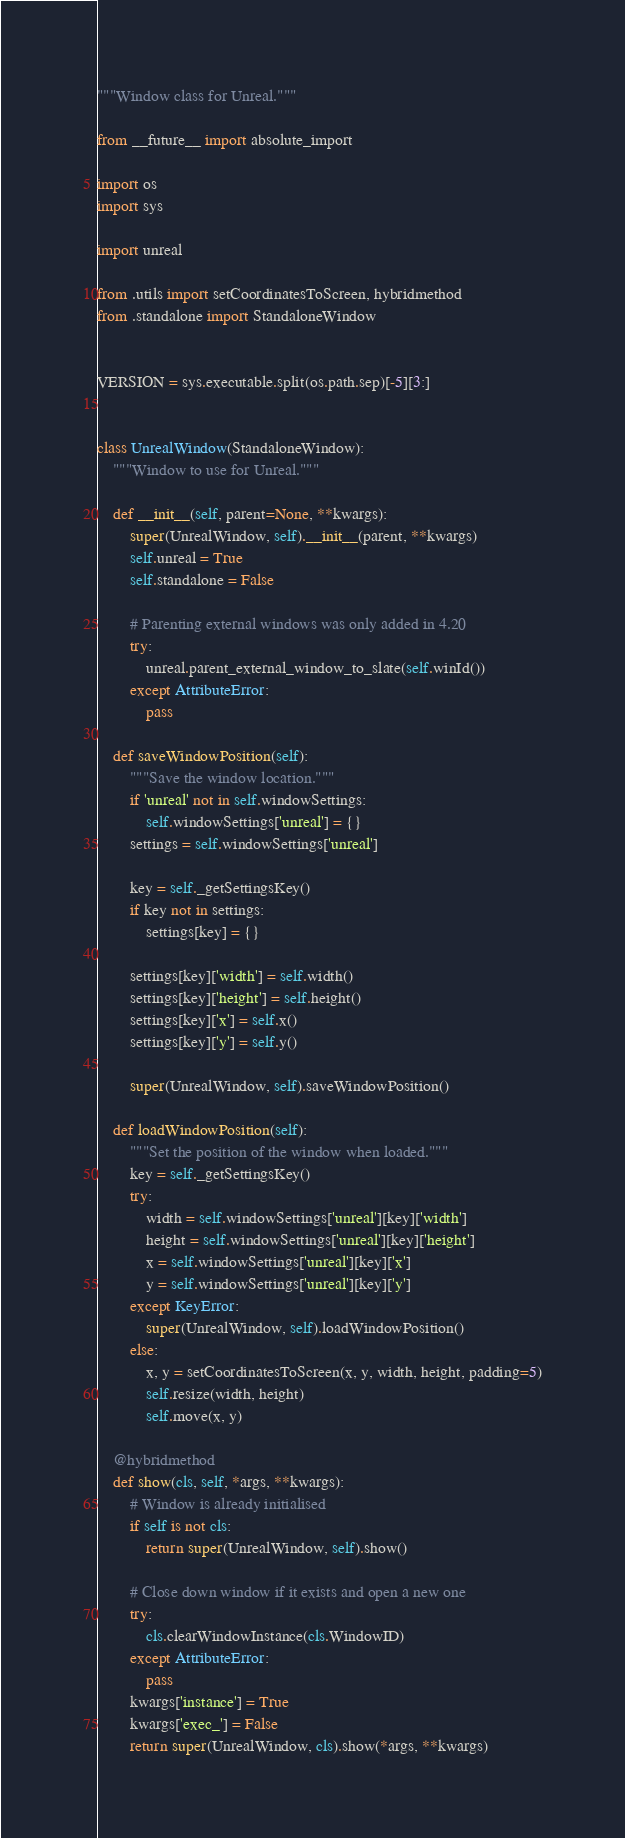Convert code to text. <code><loc_0><loc_0><loc_500><loc_500><_Python_>"""Window class for Unreal."""

from __future__ import absolute_import

import os
import sys

import unreal

from .utils import setCoordinatesToScreen, hybridmethod
from .standalone import StandaloneWindow


VERSION = sys.executable.split(os.path.sep)[-5][3:]


class UnrealWindow(StandaloneWindow):
    """Window to use for Unreal."""

    def __init__(self, parent=None, **kwargs):
        super(UnrealWindow, self).__init__(parent, **kwargs)
        self.unreal = True
        self.standalone = False

        # Parenting external windows was only added in 4.20
        try:
            unreal.parent_external_window_to_slate(self.winId())
        except AttributeError:
            pass

    def saveWindowPosition(self):
        """Save the window location."""
        if 'unreal' not in self.windowSettings:
            self.windowSettings['unreal'] = {}
        settings = self.windowSettings['unreal']

        key = self._getSettingsKey()
        if key not in settings:
            settings[key] = {}

        settings[key]['width'] = self.width()
        settings[key]['height'] = self.height()
        settings[key]['x'] = self.x()
        settings[key]['y'] = self.y()

        super(UnrealWindow, self).saveWindowPosition()

    def loadWindowPosition(self):
        """Set the position of the window when loaded."""
        key = self._getSettingsKey()
        try:
            width = self.windowSettings['unreal'][key]['width']
            height = self.windowSettings['unreal'][key]['height']
            x = self.windowSettings['unreal'][key]['x']
            y = self.windowSettings['unreal'][key]['y']
        except KeyError:
            super(UnrealWindow, self).loadWindowPosition()
        else:
            x, y = setCoordinatesToScreen(x, y, width, height, padding=5)
            self.resize(width, height)
            self.move(x, y)

    @hybridmethod
    def show(cls, self, *args, **kwargs):
        # Window is already initialised
        if self is not cls:
            return super(UnrealWindow, self).show()

        # Close down window if it exists and open a new one
        try:
            cls.clearWindowInstance(cls.WindowID)
        except AttributeError:
            pass
        kwargs['instance'] = True
        kwargs['exec_'] = False
        return super(UnrealWindow, cls).show(*args, **kwargs)
</code> 